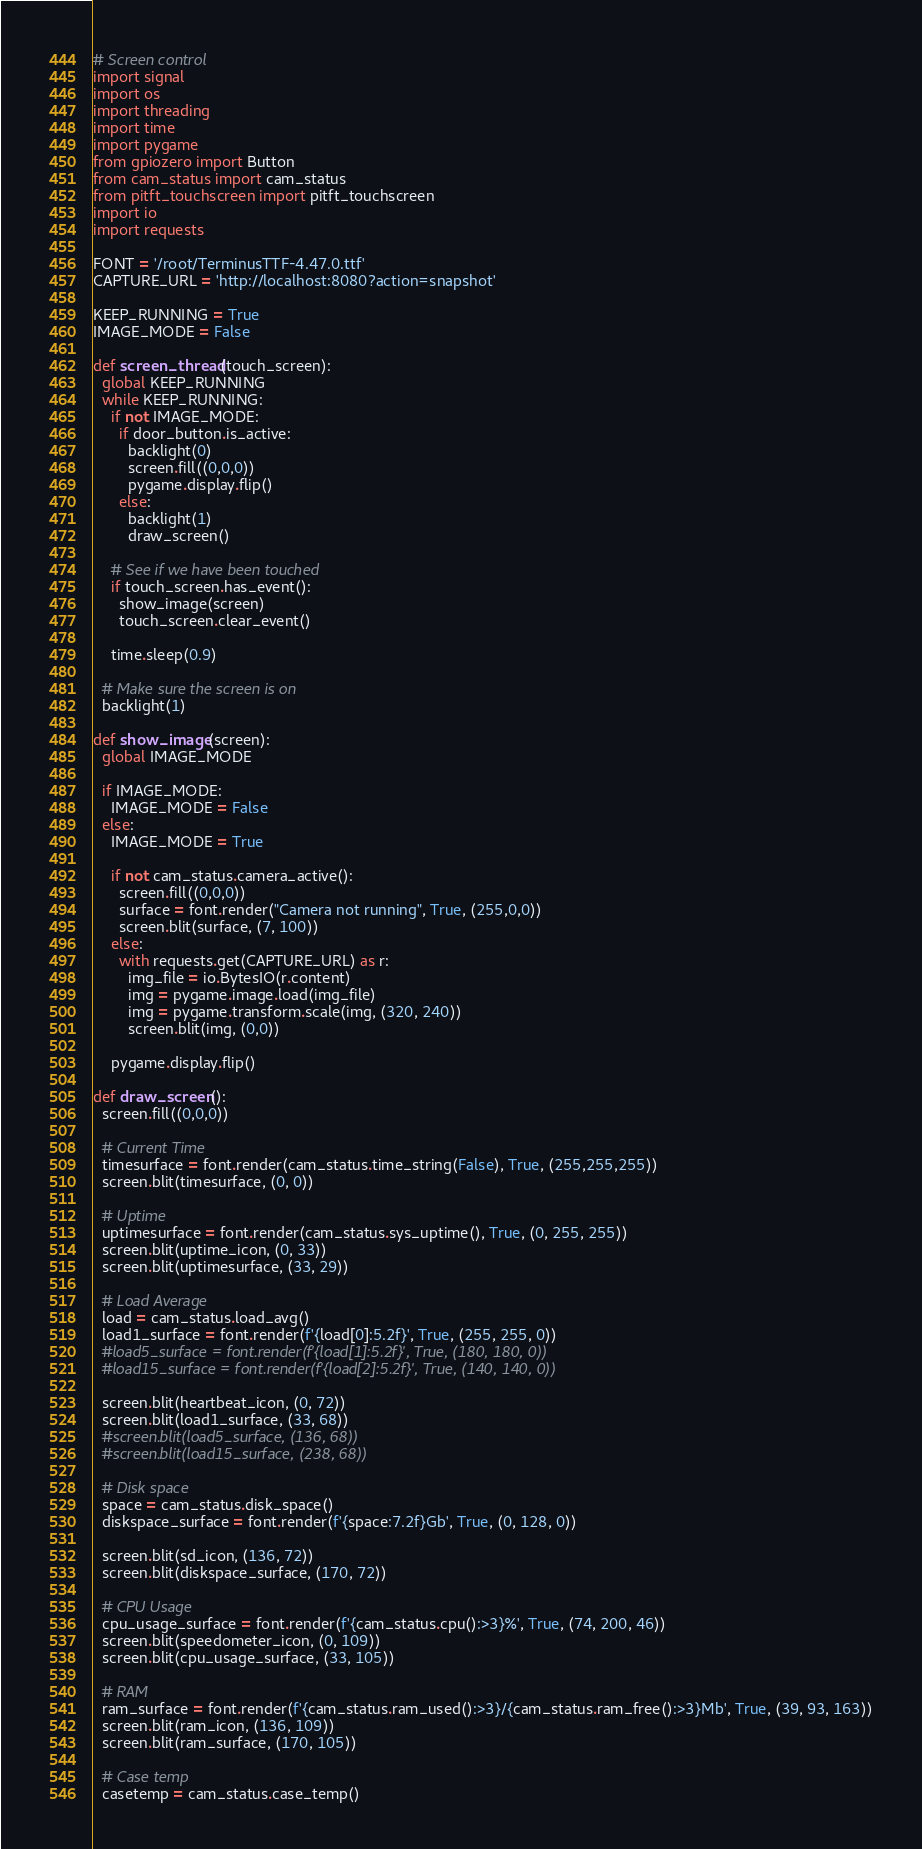Convert code to text. <code><loc_0><loc_0><loc_500><loc_500><_Python_># Screen control
import signal
import os
import threading
import time
import pygame
from gpiozero import Button
from cam_status import cam_status
from pitft_touchscreen import pitft_touchscreen
import io
import requests

FONT = '/root/TerminusTTF-4.47.0.ttf'
CAPTURE_URL = 'http://localhost:8080?action=snapshot'

KEEP_RUNNING = True
IMAGE_MODE = False

def screen_thread(touch_screen):
  global KEEP_RUNNING
  while KEEP_RUNNING:
    if not IMAGE_MODE:
      if door_button.is_active:
        backlight(0)
        screen.fill((0,0,0))
        pygame.display.flip()
      else:
        backlight(1)
        draw_screen()

    # See if we have been touched
    if touch_screen.has_event():
      show_image(screen)
      touch_screen.clear_event()

    time.sleep(0.9)

  # Make sure the screen is on
  backlight(1)

def show_image(screen):
  global IMAGE_MODE

  if IMAGE_MODE:
    IMAGE_MODE = False
  else:
    IMAGE_MODE = True

    if not cam_status.camera_active():
      screen.fill((0,0,0))
      surface = font.render("Camera not running", True, (255,0,0))
      screen.blit(surface, (7, 100))
    else:
      with requests.get(CAPTURE_URL) as r:
        img_file = io.BytesIO(r.content)
        img = pygame.image.load(img_file)
        img = pygame.transform.scale(img, (320, 240))
        screen.blit(img, (0,0))

    pygame.display.flip()
  
def draw_screen():
  screen.fill((0,0,0))

  # Current Time
  timesurface = font.render(cam_status.time_string(False), True, (255,255,255))
  screen.blit(timesurface, (0, 0))

  # Uptime
  uptimesurface = font.render(cam_status.sys_uptime(), True, (0, 255, 255))
  screen.blit(uptime_icon, (0, 33))
  screen.blit(uptimesurface, (33, 29))

  # Load Average
  load = cam_status.load_avg()
  load1_surface = font.render(f'{load[0]:5.2f}', True, (255, 255, 0))
  #load5_surface = font.render(f'{load[1]:5.2f}', True, (180, 180, 0))
  #load15_surface = font.render(f'{load[2]:5.2f}', True, (140, 140, 0))

  screen.blit(heartbeat_icon, (0, 72))
  screen.blit(load1_surface, (33, 68))
  #screen.blit(load5_surface, (136, 68))
  #screen.blit(load15_surface, (238, 68))

  # Disk space
  space = cam_status.disk_space()
  diskspace_surface = font.render(f'{space:7.2f}Gb', True, (0, 128, 0))

  screen.blit(sd_icon, (136, 72))
  screen.blit(diskspace_surface, (170, 72))

  # CPU Usage
  cpu_usage_surface = font.render(f'{cam_status.cpu():>3}%', True, (74, 200, 46))
  screen.blit(speedometer_icon, (0, 109))
  screen.blit(cpu_usage_surface, (33, 105))

  # RAM
  ram_surface = font.render(f'{cam_status.ram_used():>3}/{cam_status.ram_free():>3}Mb', True, (39, 93, 163))
  screen.blit(ram_icon, (136, 109))
  screen.blit(ram_surface, (170, 105))

  # Case temp
  casetemp = cam_status.case_temp()</code> 